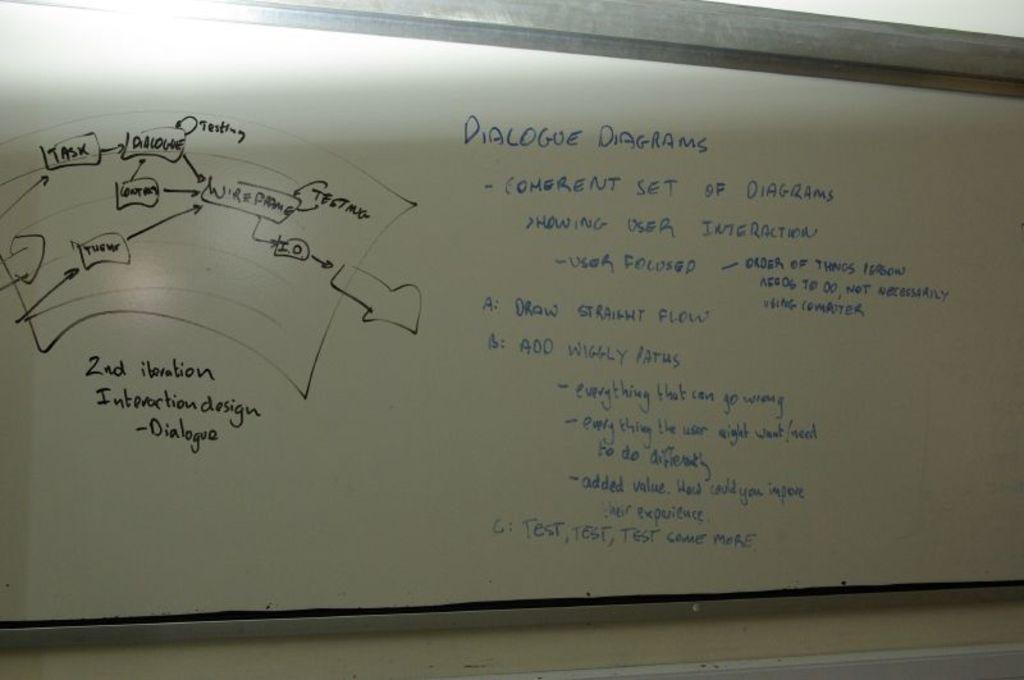<image>
Relay a brief, clear account of the picture shown. A whiteboard says "dialogue diagrams" at the top in blue marker. 